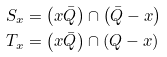<formula> <loc_0><loc_0><loc_500><loc_500>S _ { x } & = \left ( x \bar { Q } \right ) \cap \left ( \bar { Q } - x \right ) \\ T _ { x } & = \left ( x \bar { Q } \right ) \cap \left ( Q - x \right )</formula> 